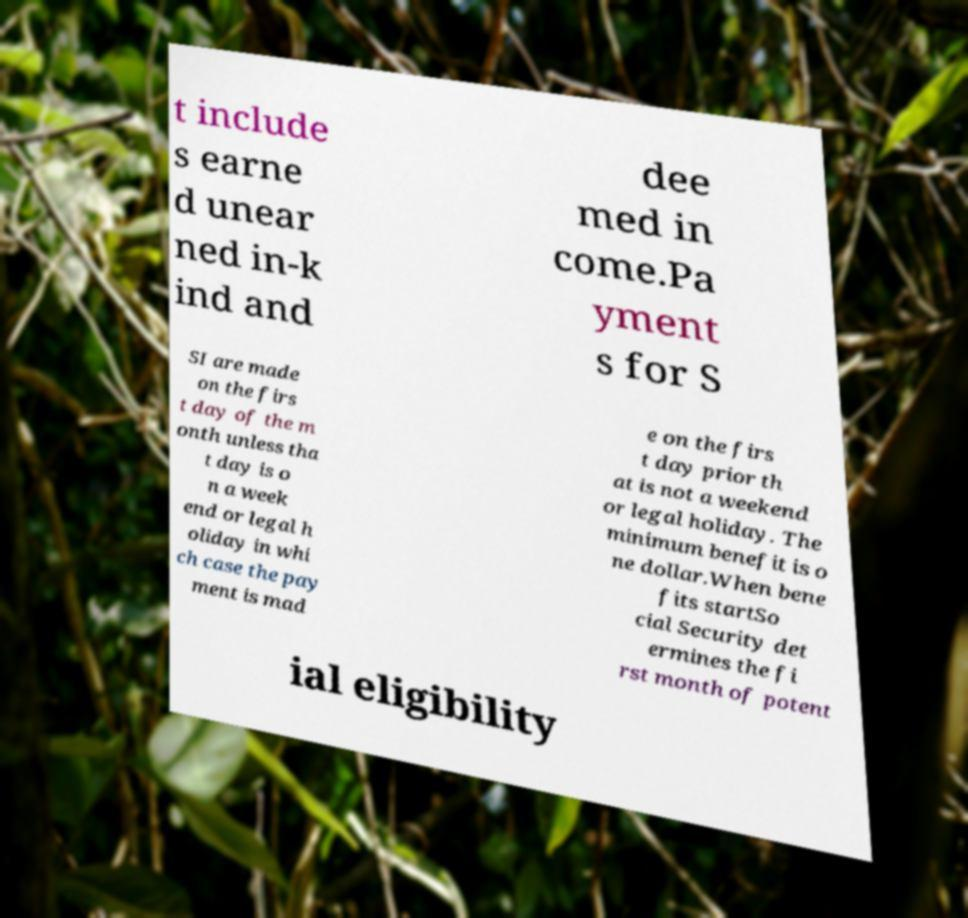For documentation purposes, I need the text within this image transcribed. Could you provide that? t include s earne d unear ned in-k ind and dee med in come.Pa yment s for S SI are made on the firs t day of the m onth unless tha t day is o n a week end or legal h oliday in whi ch case the pay ment is mad e on the firs t day prior th at is not a weekend or legal holiday. The minimum benefit is o ne dollar.When bene fits startSo cial Security det ermines the fi rst month of potent ial eligibility 